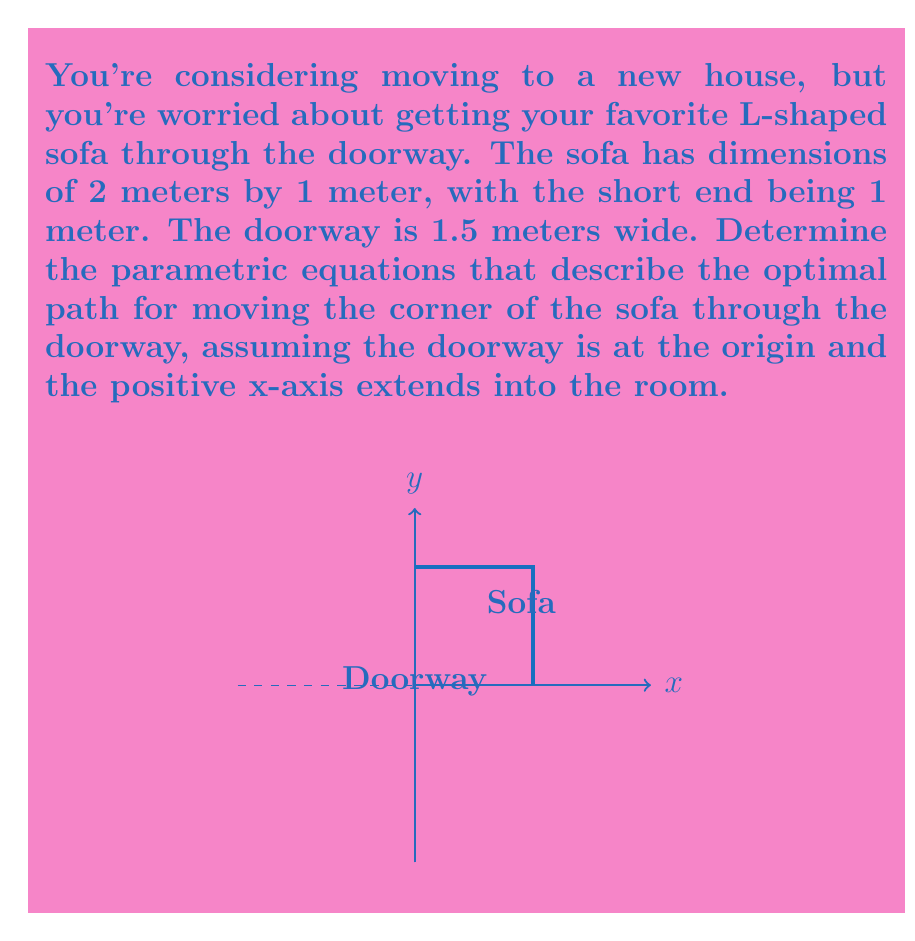Could you help me with this problem? To solve this problem, we need to consider the motion of the corner of the L-shaped sofa as it moves through the doorway. The optimal path will be a curve that allows the sofa to pass through without colliding with the doorframe.

Step 1: Understand the constraints
- The doorway width is 1.5 meters
- The sofa's short end is 1 meter
- The corner of the sofa must follow a path that keeps both ends from hitting the doorframe

Step 2: Recognize the curve
The path that satisfies these constraints is a quarter circle with radius 0.5 meters (half the width of the short end of the sofa).

Step 3: Set up the parametric equations
For a circle centered at (0.5, 1), with radius 0.5, and t representing the angle from 0 to π/2 radians:

$$x = 0.5 + 0.5\cos(t)$$
$$y = 1 - 0.5\sin(t)$$

Step 4: Verify the equations
- When t = 0, (x, y) = (1, 1), which is the starting position of the corner
- When t = π/2, (x, y) = (0.5, 0.5), which is the ending position of the corner

Step 5: Interpret the result
These parametric equations describe the path of the corner of the sofa as it moves through the doorway. The rest of the sofa will follow this path, ensuring it clears the doorframe.
Answer: $$x = 0.5 + 0.5\cos(t), y = 1 - 0.5\sin(t)$$ where $0 \leq t \leq \frac{\pi}{2}$ 